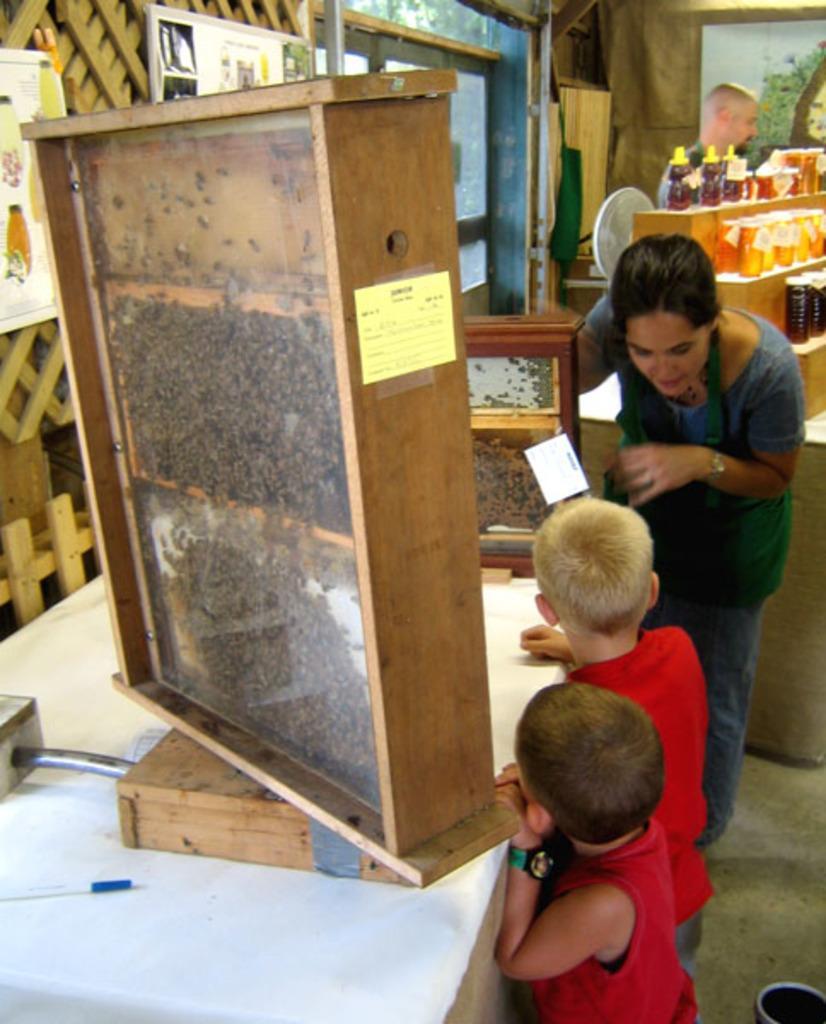How would you summarize this image in a sentence or two? In this image I can see three people. I can see the wooden objects on the table. In the background, I can see some objects in the table and a person standing near the wall. 